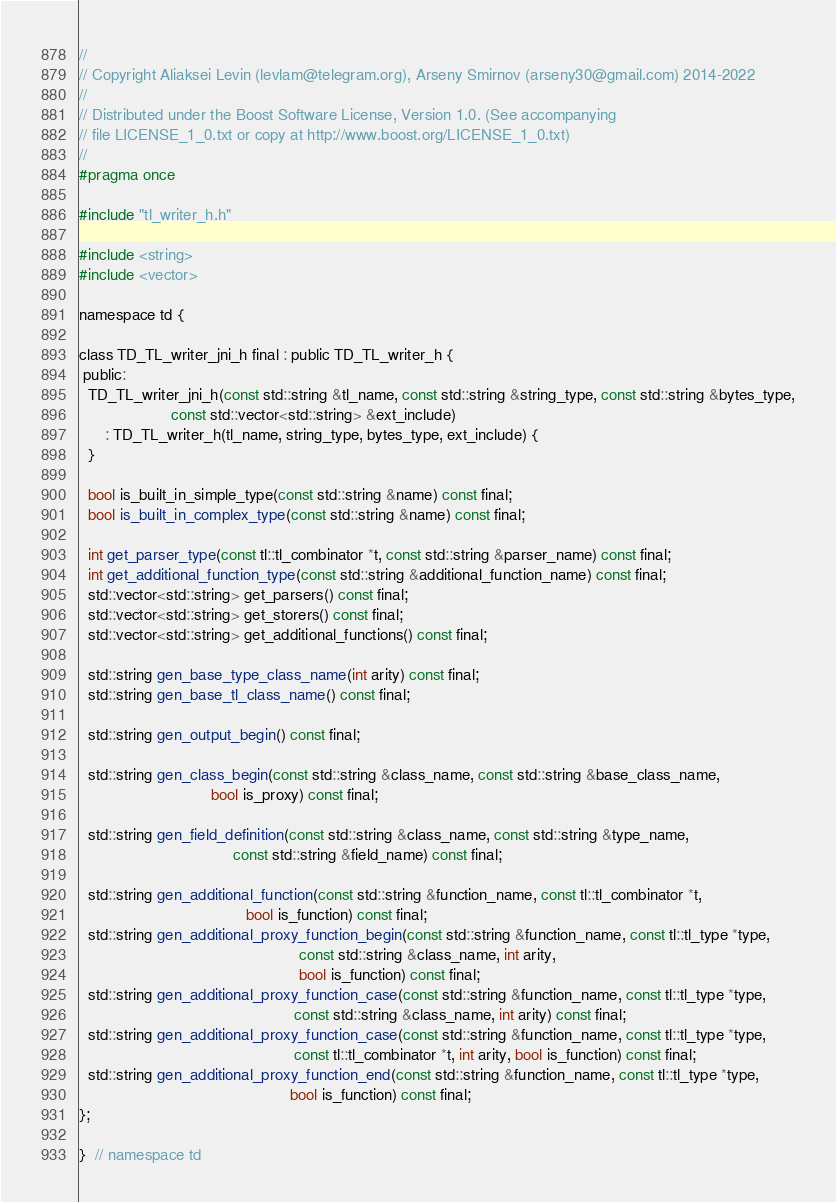<code> <loc_0><loc_0><loc_500><loc_500><_C_>//
// Copyright Aliaksei Levin (levlam@telegram.org), Arseny Smirnov (arseny30@gmail.com) 2014-2022
//
// Distributed under the Boost Software License, Version 1.0. (See accompanying
// file LICENSE_1_0.txt or copy at http://www.boost.org/LICENSE_1_0.txt)
//
#pragma once

#include "tl_writer_h.h"

#include <string>
#include <vector>

namespace td {

class TD_TL_writer_jni_h final : public TD_TL_writer_h {
 public:
  TD_TL_writer_jni_h(const std::string &tl_name, const std::string &string_type, const std::string &bytes_type,
                     const std::vector<std::string> &ext_include)
      : TD_TL_writer_h(tl_name, string_type, bytes_type, ext_include) {
  }

  bool is_built_in_simple_type(const std::string &name) const final;
  bool is_built_in_complex_type(const std::string &name) const final;

  int get_parser_type(const tl::tl_combinator *t, const std::string &parser_name) const final;
  int get_additional_function_type(const std::string &additional_function_name) const final;
  std::vector<std::string> get_parsers() const final;
  std::vector<std::string> get_storers() const final;
  std::vector<std::string> get_additional_functions() const final;

  std::string gen_base_type_class_name(int arity) const final;
  std::string gen_base_tl_class_name() const final;

  std::string gen_output_begin() const final;

  std::string gen_class_begin(const std::string &class_name, const std::string &base_class_name,
                              bool is_proxy) const final;

  std::string gen_field_definition(const std::string &class_name, const std::string &type_name,
                                   const std::string &field_name) const final;

  std::string gen_additional_function(const std::string &function_name, const tl::tl_combinator *t,
                                      bool is_function) const final;
  std::string gen_additional_proxy_function_begin(const std::string &function_name, const tl::tl_type *type,
                                                  const std::string &class_name, int arity,
                                                  bool is_function) const final;
  std::string gen_additional_proxy_function_case(const std::string &function_name, const tl::tl_type *type,
                                                 const std::string &class_name, int arity) const final;
  std::string gen_additional_proxy_function_case(const std::string &function_name, const tl::tl_type *type,
                                                 const tl::tl_combinator *t, int arity, bool is_function) const final;
  std::string gen_additional_proxy_function_end(const std::string &function_name, const tl::tl_type *type,
                                                bool is_function) const final;
};

}  // namespace td
</code> 